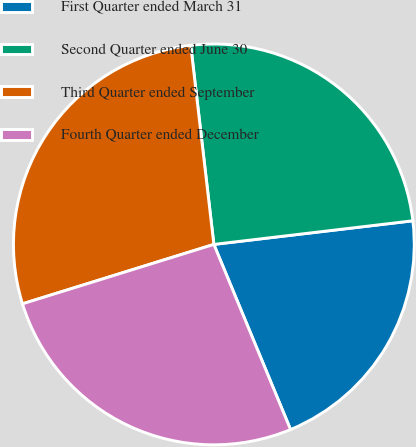Convert chart. <chart><loc_0><loc_0><loc_500><loc_500><pie_chart><fcel>First Quarter ended March 31<fcel>Second Quarter ended June 30<fcel>Third Quarter ended September<fcel>Fourth Quarter ended December<nl><fcel>20.63%<fcel>24.96%<fcel>27.95%<fcel>26.46%<nl></chart> 